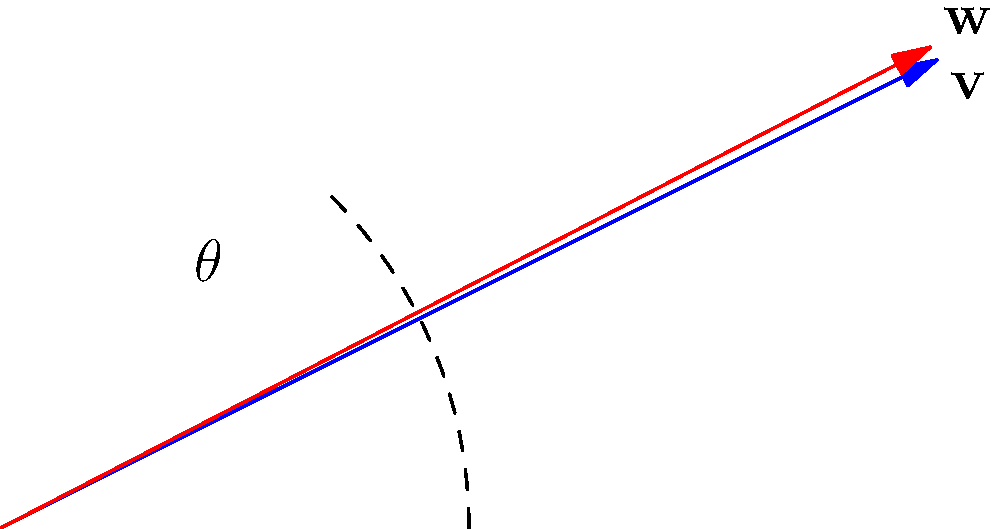In a music video sequence, you want to create a dynamic visual effect where a graphic element rotates in sync with the beat of the song. If the original vector $\mathbf{v} = (2,1)$ represents the initial position of the graphic element, and you want to rotate it by 45° counterclockwise to match a specific beat, what would be the coordinates of the resulting vector $\mathbf{w}$? To solve this problem, we'll follow these steps:

1) First, recall the formula for rotating a vector $(x,y)$ by an angle $\theta$ counterclockwise:
   $$(x', y') = (x \cos\theta - y \sin\theta, x \sin\theta + y \cos\theta)$$

2) In this case, $\mathbf{v} = (2,1)$, so $x=2$ and $y=1$.

3) The angle of rotation is 45°, which in radians is $\theta = \frac{\pi}{4}$.

4) We know that $\cos(\frac{\pi}{4}) = \sin(\frac{\pi}{4}) = \frac{\sqrt{2}}{2}$.

5) Now, let's substitute these values into our rotation formula:

   $x' = 2 \cos(\frac{\pi}{4}) - 1 \sin(\frac{\pi}{4}) = 2(\frac{\sqrt{2}}{2}) - 1(\frac{\sqrt{2}}{2}) = \sqrt{2} - \frac{\sqrt{2}}{2} = \frac{\sqrt{2}}{2}$

   $y' = 2 \sin(\frac{\pi}{4}) + 1 \cos(\frac{\pi}{4}) = 2(\frac{\sqrt{2}}{2}) + 1(\frac{\sqrt{2}}{2}) = \sqrt{2} + \frac{\sqrt{2}}{2} = \frac{3\sqrt{2}}{2}$

6) Therefore, the coordinates of the rotated vector $\mathbf{w}$ are $(\frac{\sqrt{2}}{2}, \frac{3\sqrt{2}}{2})$.
Answer: $(\frac{\sqrt{2}}{2}, \frac{3\sqrt{2}}{2})$ 